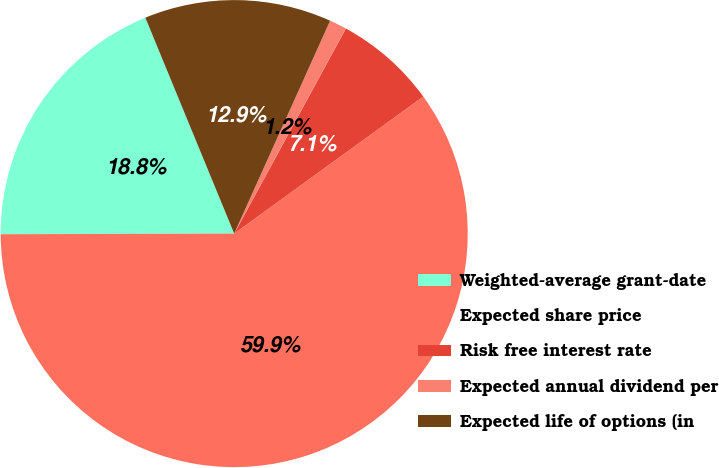Convert chart to OTSL. <chart><loc_0><loc_0><loc_500><loc_500><pie_chart><fcel>Weighted-average grant-date<fcel>Expected share price<fcel>Risk free interest rate<fcel>Expected annual dividend per<fcel>Expected life of options (in<nl><fcel>18.83%<fcel>59.94%<fcel>7.08%<fcel>1.2%<fcel>12.95%<nl></chart> 